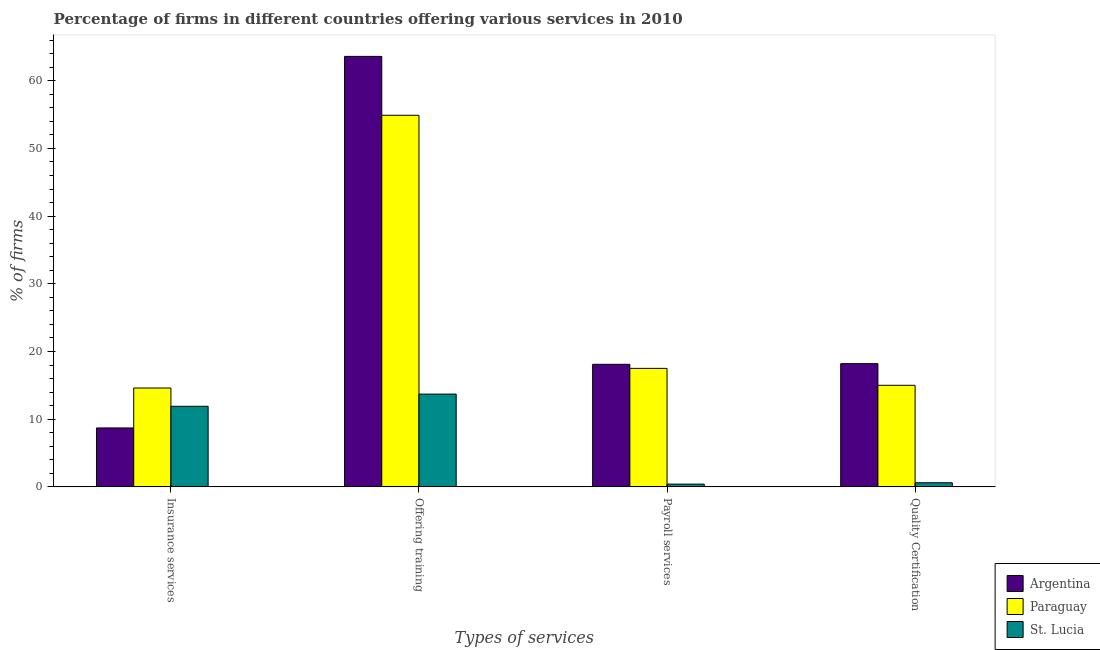How many different coloured bars are there?
Your answer should be very brief. 3. How many bars are there on the 2nd tick from the left?
Give a very brief answer. 3. How many bars are there on the 2nd tick from the right?
Your response must be concise. 3. What is the label of the 2nd group of bars from the left?
Provide a short and direct response. Offering training. What is the percentage of firms offering insurance services in St. Lucia?
Provide a succinct answer. 11.9. Across all countries, what is the maximum percentage of firms offering training?
Make the answer very short. 63.6. Across all countries, what is the minimum percentage of firms offering training?
Your response must be concise. 13.7. In which country was the percentage of firms offering insurance services maximum?
Your response must be concise. Paraguay. In which country was the percentage of firms offering insurance services minimum?
Offer a very short reply. Argentina. What is the difference between the percentage of firms offering payroll services in St. Lucia and the percentage of firms offering insurance services in Argentina?
Your response must be concise. -8.3. What is the average percentage of firms offering training per country?
Provide a succinct answer. 44.07. What is the difference between the percentage of firms offering quality certification and percentage of firms offering payroll services in St. Lucia?
Offer a very short reply. 0.2. What is the ratio of the percentage of firms offering training in Paraguay to that in St. Lucia?
Your answer should be very brief. 4.01. What is the difference between the highest and the second highest percentage of firms offering quality certification?
Keep it short and to the point. 3.2. What is the difference between the highest and the lowest percentage of firms offering quality certification?
Provide a succinct answer. 17.6. Is it the case that in every country, the sum of the percentage of firms offering payroll services and percentage of firms offering training is greater than the sum of percentage of firms offering quality certification and percentage of firms offering insurance services?
Keep it short and to the point. No. What does the 3rd bar from the left in Payroll services represents?
Ensure brevity in your answer.  St. Lucia. What does the 1st bar from the right in Offering training represents?
Keep it short and to the point. St. Lucia. Is it the case that in every country, the sum of the percentage of firms offering insurance services and percentage of firms offering training is greater than the percentage of firms offering payroll services?
Your response must be concise. Yes. How many bars are there?
Provide a short and direct response. 12. Are all the bars in the graph horizontal?
Offer a terse response. No. How many countries are there in the graph?
Provide a short and direct response. 3. What is the difference between two consecutive major ticks on the Y-axis?
Provide a succinct answer. 10. Are the values on the major ticks of Y-axis written in scientific E-notation?
Your answer should be compact. No. How are the legend labels stacked?
Offer a terse response. Vertical. What is the title of the graph?
Provide a succinct answer. Percentage of firms in different countries offering various services in 2010. What is the label or title of the X-axis?
Make the answer very short. Types of services. What is the label or title of the Y-axis?
Keep it short and to the point. % of firms. What is the % of firms in Argentina in Insurance services?
Keep it short and to the point. 8.7. What is the % of firms of Paraguay in Insurance services?
Offer a terse response. 14.6. What is the % of firms of St. Lucia in Insurance services?
Offer a terse response. 11.9. What is the % of firms in Argentina in Offering training?
Keep it short and to the point. 63.6. What is the % of firms of Paraguay in Offering training?
Provide a short and direct response. 54.9. What is the % of firms in St. Lucia in Offering training?
Your response must be concise. 13.7. What is the % of firms of Paraguay in Quality Certification?
Your answer should be compact. 15. Across all Types of services, what is the maximum % of firms of Argentina?
Offer a very short reply. 63.6. Across all Types of services, what is the maximum % of firms in Paraguay?
Give a very brief answer. 54.9. Across all Types of services, what is the minimum % of firms in St. Lucia?
Give a very brief answer. 0.4. What is the total % of firms in Argentina in the graph?
Provide a succinct answer. 108.6. What is the total % of firms of Paraguay in the graph?
Keep it short and to the point. 102. What is the total % of firms of St. Lucia in the graph?
Offer a terse response. 26.6. What is the difference between the % of firms of Argentina in Insurance services and that in Offering training?
Provide a succinct answer. -54.9. What is the difference between the % of firms in Paraguay in Insurance services and that in Offering training?
Provide a succinct answer. -40.3. What is the difference between the % of firms in St. Lucia in Insurance services and that in Offering training?
Keep it short and to the point. -1.8. What is the difference between the % of firms in St. Lucia in Insurance services and that in Payroll services?
Provide a short and direct response. 11.5. What is the difference between the % of firms of Argentina in Insurance services and that in Quality Certification?
Your response must be concise. -9.5. What is the difference between the % of firms in Paraguay in Insurance services and that in Quality Certification?
Your answer should be very brief. -0.4. What is the difference between the % of firms of Argentina in Offering training and that in Payroll services?
Ensure brevity in your answer.  45.5. What is the difference between the % of firms of Paraguay in Offering training and that in Payroll services?
Your response must be concise. 37.4. What is the difference between the % of firms in St. Lucia in Offering training and that in Payroll services?
Give a very brief answer. 13.3. What is the difference between the % of firms of Argentina in Offering training and that in Quality Certification?
Offer a very short reply. 45.4. What is the difference between the % of firms in Paraguay in Offering training and that in Quality Certification?
Keep it short and to the point. 39.9. What is the difference between the % of firms in St. Lucia in Payroll services and that in Quality Certification?
Make the answer very short. -0.2. What is the difference between the % of firms of Argentina in Insurance services and the % of firms of Paraguay in Offering training?
Offer a terse response. -46.2. What is the difference between the % of firms of Argentina in Insurance services and the % of firms of St. Lucia in Offering training?
Offer a very short reply. -5. What is the difference between the % of firms of Paraguay in Insurance services and the % of firms of St. Lucia in Payroll services?
Your response must be concise. 14.2. What is the difference between the % of firms in Argentina in Insurance services and the % of firms in St. Lucia in Quality Certification?
Keep it short and to the point. 8.1. What is the difference between the % of firms in Paraguay in Insurance services and the % of firms in St. Lucia in Quality Certification?
Offer a terse response. 14. What is the difference between the % of firms in Argentina in Offering training and the % of firms in Paraguay in Payroll services?
Ensure brevity in your answer.  46.1. What is the difference between the % of firms in Argentina in Offering training and the % of firms in St. Lucia in Payroll services?
Give a very brief answer. 63.2. What is the difference between the % of firms in Paraguay in Offering training and the % of firms in St. Lucia in Payroll services?
Provide a short and direct response. 54.5. What is the difference between the % of firms of Argentina in Offering training and the % of firms of Paraguay in Quality Certification?
Your response must be concise. 48.6. What is the difference between the % of firms of Paraguay in Offering training and the % of firms of St. Lucia in Quality Certification?
Keep it short and to the point. 54.3. What is the difference between the % of firms in Paraguay in Payroll services and the % of firms in St. Lucia in Quality Certification?
Make the answer very short. 16.9. What is the average % of firms of Argentina per Types of services?
Offer a very short reply. 27.15. What is the average % of firms in Paraguay per Types of services?
Your response must be concise. 25.5. What is the average % of firms in St. Lucia per Types of services?
Your answer should be compact. 6.65. What is the difference between the % of firms in Argentina and % of firms in St. Lucia in Insurance services?
Provide a short and direct response. -3.2. What is the difference between the % of firms in Paraguay and % of firms in St. Lucia in Insurance services?
Keep it short and to the point. 2.7. What is the difference between the % of firms of Argentina and % of firms of Paraguay in Offering training?
Offer a terse response. 8.7. What is the difference between the % of firms in Argentina and % of firms in St. Lucia in Offering training?
Ensure brevity in your answer.  49.9. What is the difference between the % of firms of Paraguay and % of firms of St. Lucia in Offering training?
Your response must be concise. 41.2. What is the difference between the % of firms in Argentina and % of firms in St. Lucia in Payroll services?
Ensure brevity in your answer.  17.7. What is the difference between the % of firms in Paraguay and % of firms in St. Lucia in Payroll services?
Keep it short and to the point. 17.1. What is the difference between the % of firms in Paraguay and % of firms in St. Lucia in Quality Certification?
Your answer should be compact. 14.4. What is the ratio of the % of firms in Argentina in Insurance services to that in Offering training?
Ensure brevity in your answer.  0.14. What is the ratio of the % of firms in Paraguay in Insurance services to that in Offering training?
Provide a short and direct response. 0.27. What is the ratio of the % of firms in St. Lucia in Insurance services to that in Offering training?
Make the answer very short. 0.87. What is the ratio of the % of firms in Argentina in Insurance services to that in Payroll services?
Your answer should be compact. 0.48. What is the ratio of the % of firms of Paraguay in Insurance services to that in Payroll services?
Offer a very short reply. 0.83. What is the ratio of the % of firms of St. Lucia in Insurance services to that in Payroll services?
Provide a succinct answer. 29.75. What is the ratio of the % of firms of Argentina in Insurance services to that in Quality Certification?
Provide a succinct answer. 0.48. What is the ratio of the % of firms in Paraguay in Insurance services to that in Quality Certification?
Offer a terse response. 0.97. What is the ratio of the % of firms in St. Lucia in Insurance services to that in Quality Certification?
Make the answer very short. 19.83. What is the ratio of the % of firms of Argentina in Offering training to that in Payroll services?
Keep it short and to the point. 3.51. What is the ratio of the % of firms in Paraguay in Offering training to that in Payroll services?
Make the answer very short. 3.14. What is the ratio of the % of firms in St. Lucia in Offering training to that in Payroll services?
Offer a very short reply. 34.25. What is the ratio of the % of firms of Argentina in Offering training to that in Quality Certification?
Give a very brief answer. 3.49. What is the ratio of the % of firms of Paraguay in Offering training to that in Quality Certification?
Ensure brevity in your answer.  3.66. What is the ratio of the % of firms in St. Lucia in Offering training to that in Quality Certification?
Your response must be concise. 22.83. What is the ratio of the % of firms of Paraguay in Payroll services to that in Quality Certification?
Give a very brief answer. 1.17. What is the difference between the highest and the second highest % of firms of Argentina?
Provide a succinct answer. 45.4. What is the difference between the highest and the second highest % of firms of Paraguay?
Provide a succinct answer. 37.4. What is the difference between the highest and the lowest % of firms in Argentina?
Your answer should be very brief. 54.9. What is the difference between the highest and the lowest % of firms in Paraguay?
Give a very brief answer. 40.3. What is the difference between the highest and the lowest % of firms of St. Lucia?
Give a very brief answer. 13.3. 